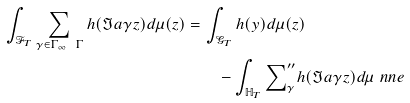<formula> <loc_0><loc_0><loc_500><loc_500>\int _ { \mathcal { F } _ { T } } \sum _ { \gamma \in \Gamma _ { \infty } \ \Gamma } h ( \Im a \gamma z ) d \mu ( z ) = & \, \int _ { \mathcal { G } _ { T } } h ( y ) d \mu ( z ) \\ & \quad - \int _ { \mathbb { H } _ { T } } { \sum } ^ { \prime \prime } _ { \gamma } h ( \Im a \gamma z ) d \mu \ n n e</formula> 